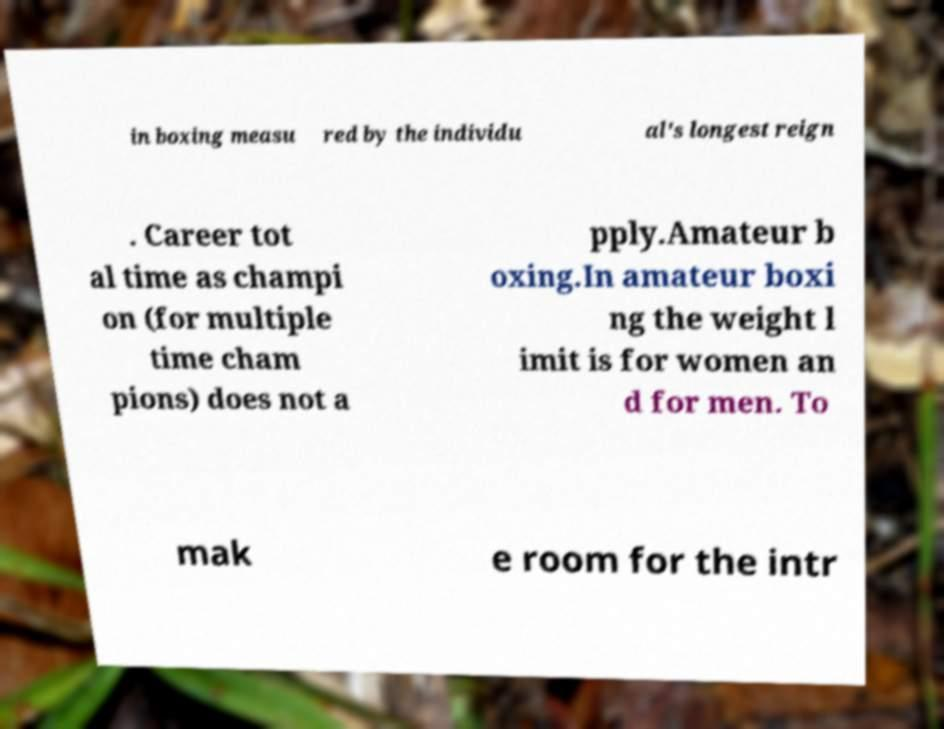Could you extract and type out the text from this image? in boxing measu red by the individu al's longest reign . Career tot al time as champi on (for multiple time cham pions) does not a pply.Amateur b oxing.In amateur boxi ng the weight l imit is for women an d for men. To mak e room for the intr 